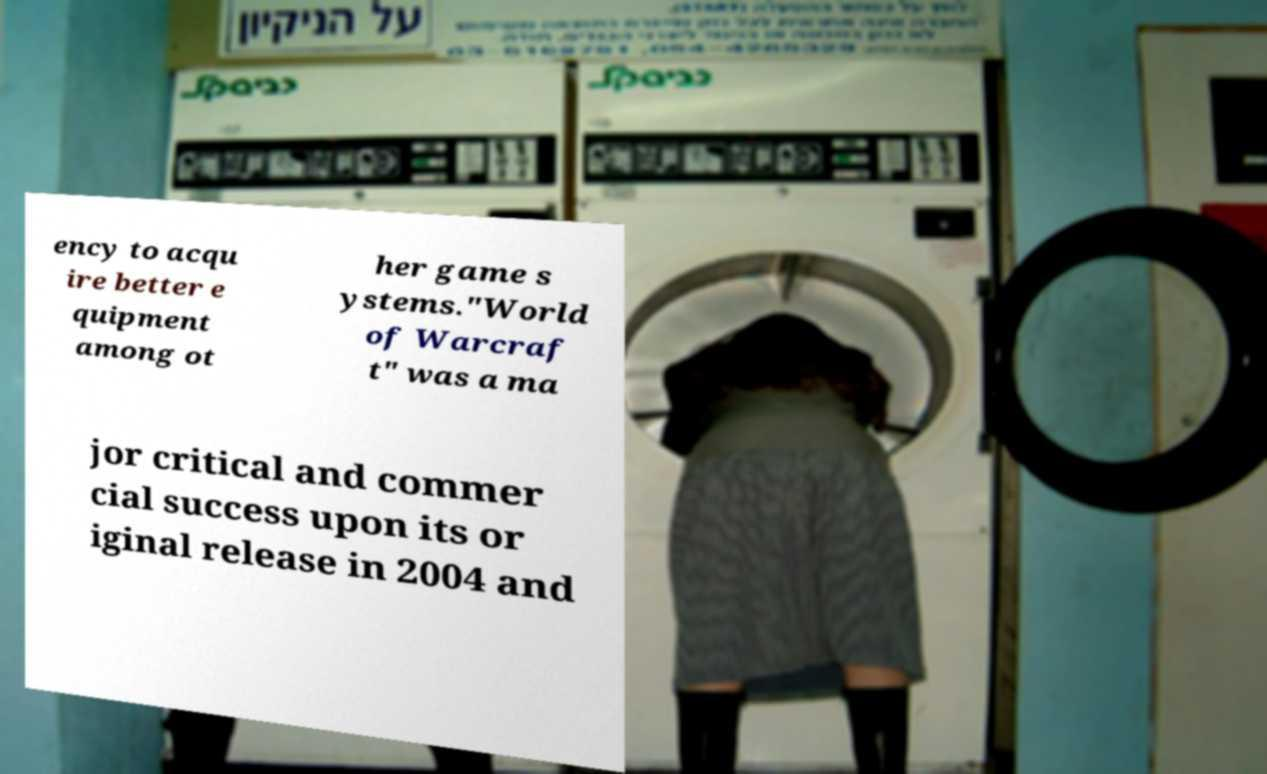Please identify and transcribe the text found in this image. ency to acqu ire better e quipment among ot her game s ystems."World of Warcraf t" was a ma jor critical and commer cial success upon its or iginal release in 2004 and 